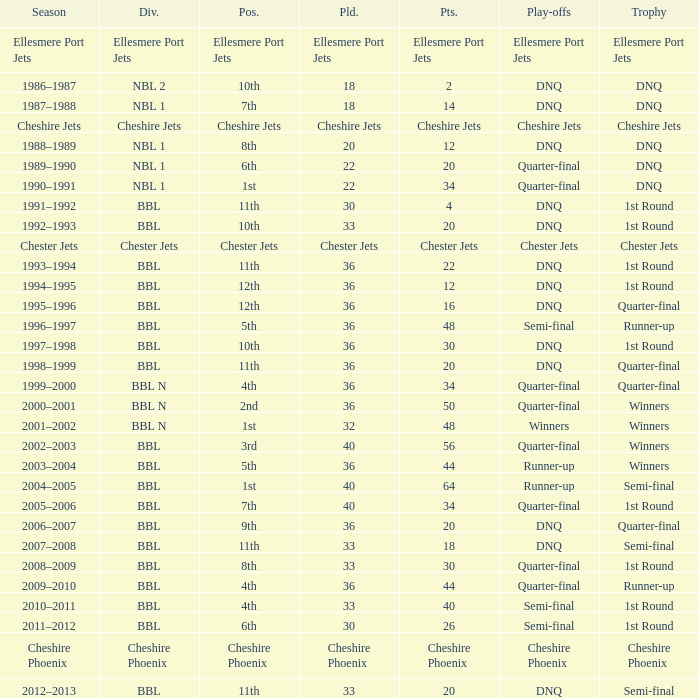Which team managed to score 56 points during the play-off quarter-final match? 3rd. 